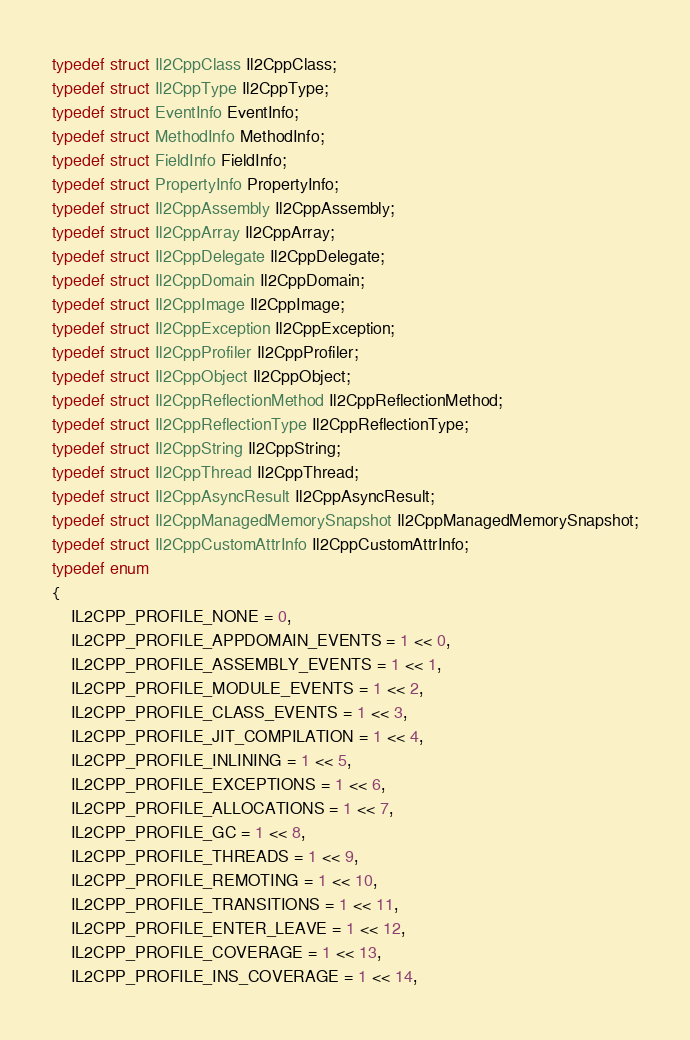<code> <loc_0><loc_0><loc_500><loc_500><_C_>typedef struct Il2CppClass Il2CppClass;
typedef struct Il2CppType Il2CppType;
typedef struct EventInfo EventInfo;
typedef struct MethodInfo MethodInfo;
typedef struct FieldInfo FieldInfo;
typedef struct PropertyInfo PropertyInfo;
typedef struct Il2CppAssembly Il2CppAssembly;
typedef struct Il2CppArray Il2CppArray;
typedef struct Il2CppDelegate Il2CppDelegate;
typedef struct Il2CppDomain Il2CppDomain;
typedef struct Il2CppImage Il2CppImage;
typedef struct Il2CppException Il2CppException;
typedef struct Il2CppProfiler Il2CppProfiler;
typedef struct Il2CppObject Il2CppObject;
typedef struct Il2CppReflectionMethod Il2CppReflectionMethod;
typedef struct Il2CppReflectionType Il2CppReflectionType;
typedef struct Il2CppString Il2CppString;
typedef struct Il2CppThread Il2CppThread;
typedef struct Il2CppAsyncResult Il2CppAsyncResult;
typedef struct Il2CppManagedMemorySnapshot Il2CppManagedMemorySnapshot;
typedef struct Il2CppCustomAttrInfo Il2CppCustomAttrInfo;
typedef enum
{
    IL2CPP_PROFILE_NONE = 0,
    IL2CPP_PROFILE_APPDOMAIN_EVENTS = 1 << 0,
    IL2CPP_PROFILE_ASSEMBLY_EVENTS = 1 << 1,
    IL2CPP_PROFILE_MODULE_EVENTS = 1 << 2,
    IL2CPP_PROFILE_CLASS_EVENTS = 1 << 3,
    IL2CPP_PROFILE_JIT_COMPILATION = 1 << 4,
    IL2CPP_PROFILE_INLINING = 1 << 5,
    IL2CPP_PROFILE_EXCEPTIONS = 1 << 6,
    IL2CPP_PROFILE_ALLOCATIONS = 1 << 7,
    IL2CPP_PROFILE_GC = 1 << 8,
    IL2CPP_PROFILE_THREADS = 1 << 9,
    IL2CPP_PROFILE_REMOTING = 1 << 10,
    IL2CPP_PROFILE_TRANSITIONS = 1 << 11,
    IL2CPP_PROFILE_ENTER_LEAVE = 1 << 12,
    IL2CPP_PROFILE_COVERAGE = 1 << 13,
    IL2CPP_PROFILE_INS_COVERAGE = 1 << 14,</code> 